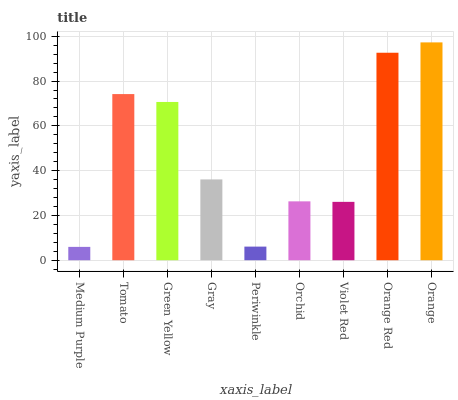Is Medium Purple the minimum?
Answer yes or no. Yes. Is Orange the maximum?
Answer yes or no. Yes. Is Tomato the minimum?
Answer yes or no. No. Is Tomato the maximum?
Answer yes or no. No. Is Tomato greater than Medium Purple?
Answer yes or no. Yes. Is Medium Purple less than Tomato?
Answer yes or no. Yes. Is Medium Purple greater than Tomato?
Answer yes or no. No. Is Tomato less than Medium Purple?
Answer yes or no. No. Is Gray the high median?
Answer yes or no. Yes. Is Gray the low median?
Answer yes or no. Yes. Is Medium Purple the high median?
Answer yes or no. No. Is Orange the low median?
Answer yes or no. No. 